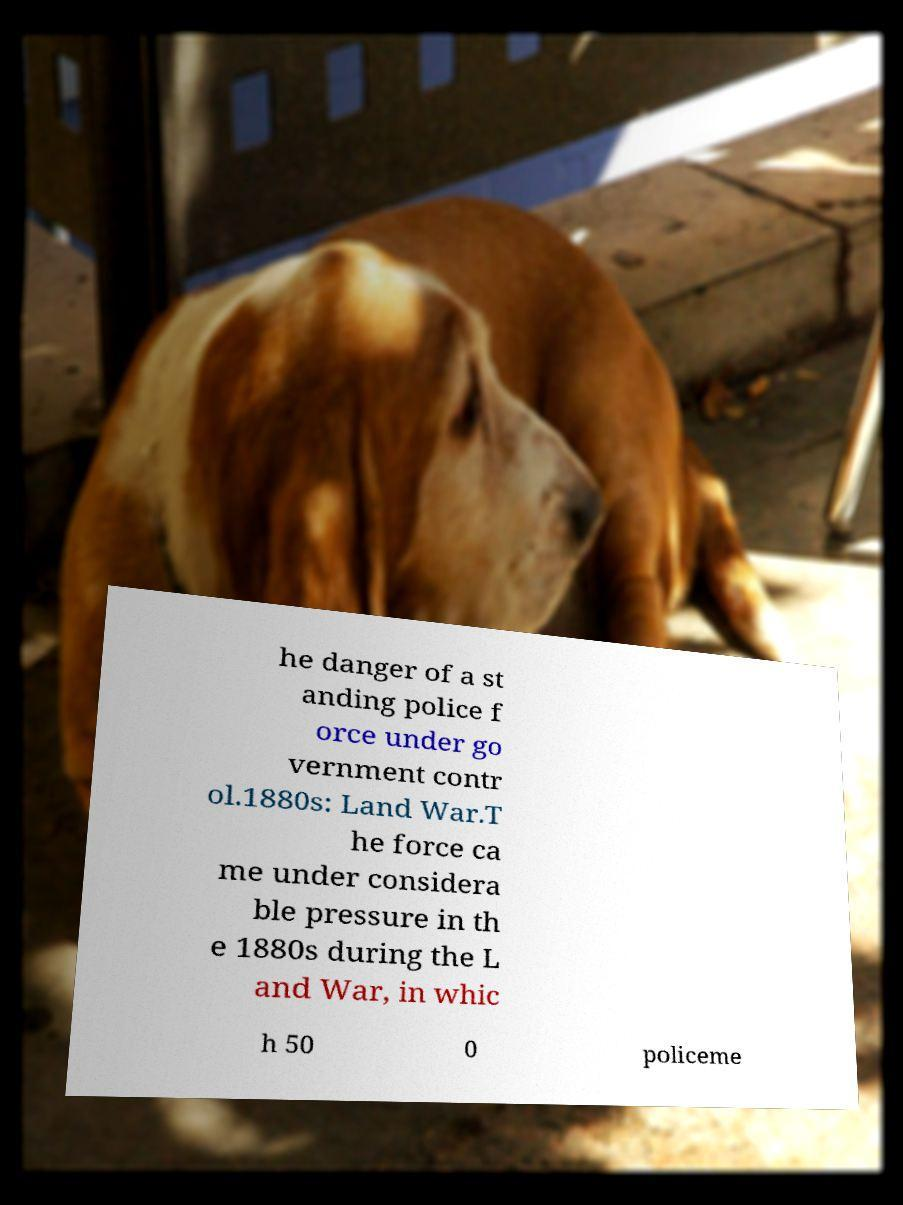For documentation purposes, I need the text within this image transcribed. Could you provide that? he danger of a st anding police f orce under go vernment contr ol.1880s: Land War.T he force ca me under considera ble pressure in th e 1880s during the L and War, in whic h 50 0 policeme 